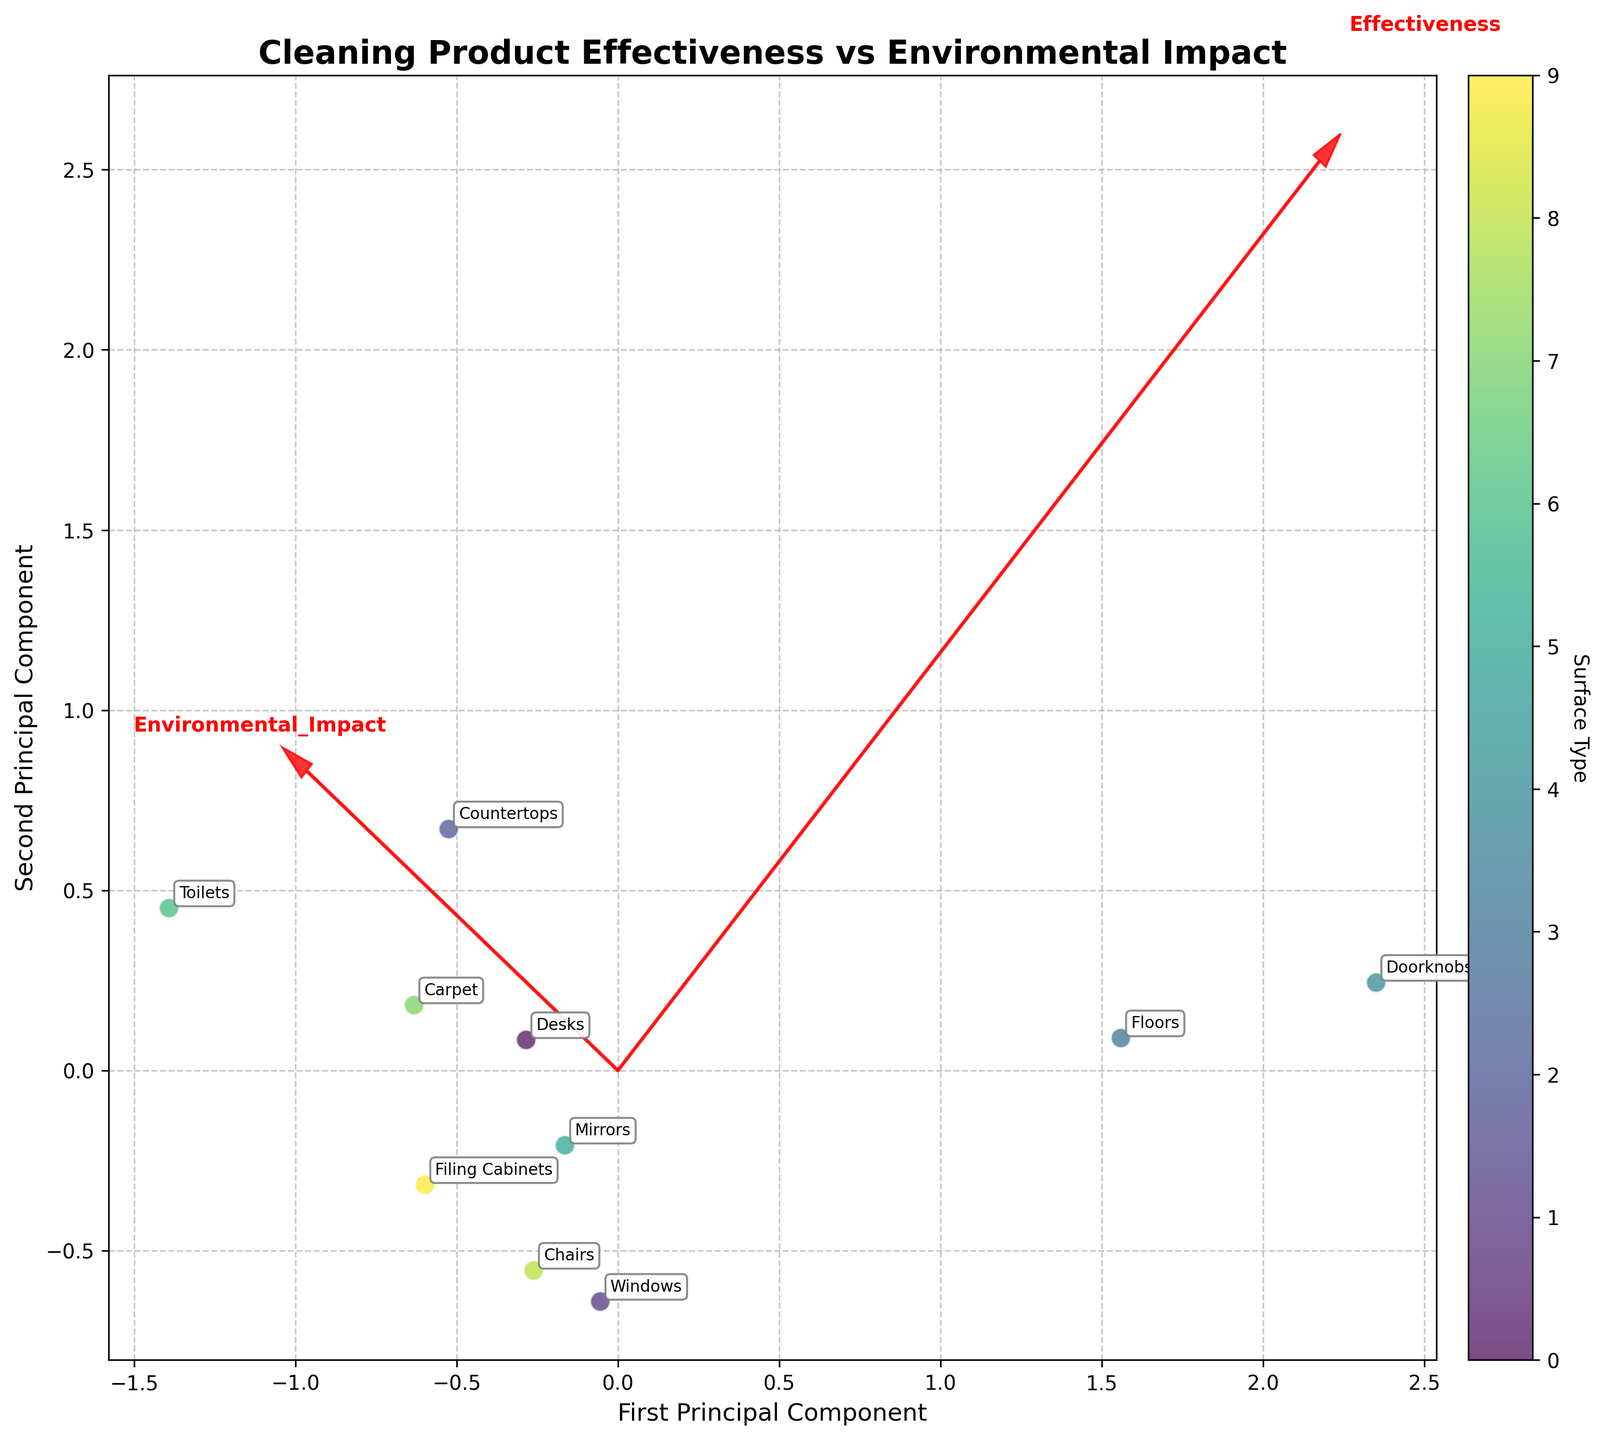what is the title of the plot? The title can be found at the top of the plot. It summarizes the overall theme or subject of the plot.
Answer: Cleaning Product Effectiveness vs Environmental Impact how many arrows are there on the plot? The plot contains arrows that represent the feature vectors of the principal components. By counting these arrows, we can determine the number of principal component directions visualized.
Answer: 2 which product is closest to the first principal component? To find the product closest to the first principal component, observe the data points projected along the x-axis and identify the one closest to the origin horizontally.
Answer: Method Glass Cleaner what is the relationship between effectiveness and environmental impact? The arrows indicate the direction and magnitude of each variable’s contribution to the principal components. By examining their lengths and directions, we can infer the relationship.
Answer: Effectiveness and environmental impact have a positive correlation which product has the highest effectiveness? Check the data point labeled with the highest value along the axis associated with effectiveness.
Answer: Lysol Disinfectant Spray which surface types have products with both high effectiveness and low environmental impact? Look for data points located in the upper-left quadrant where effectiveness is high and environmental impact is low, and note their labels.
Answer: Windows and Chairs what is the average effectiveness of products used for glass surfaces? Identify the effectiveness values for products used on glass surfaces, sum them, and divide by the number of those products. The surfaces in question here are Windows and Mirrors.
Answer: (8.2 + 7.8) / 2 = 8.0 which product has the highest environmental impact? Identify the data point with the highest value along the axis representing environmental impact.
Answer: Lysol Disinfectant Spray is there any product that has both low effectiveness and low environmental impact? Look in the lower-left quadrant for products with both low scores in effectiveness and environmental impact, and note their labels.
Answer: Ecover Toilet Cleaner compare the placement of products used on desks and carpets. Check where the points for desks and carpets are located in the biplot. Look at their relative positions on the graph.
Answer: The product for desks is slightly more effective and has a similar environmental impact compared to the product for carpets 